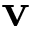Convert formula to latex. <formula><loc_0><loc_0><loc_500><loc_500>{ v }</formula> 